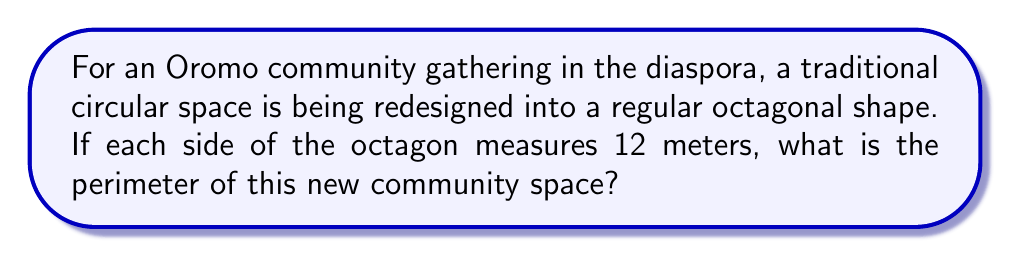Solve this math problem. Let's approach this step-by-step:

1) First, recall that a regular octagon has 8 equal sides.

2) We are given that each side measures 12 meters.

3) To find the perimeter, we need to sum up the lengths of all sides.

4) In mathematical terms, this can be expressed as:

   $$\text{Perimeter} = 8 \times \text{side length}$$

5) Substituting the given side length:

   $$\text{Perimeter} = 8 \times 12\text{ m}$$

6) Performing the multiplication:

   $$\text{Perimeter} = 96\text{ m}$$

Therefore, the perimeter of the octagonal community gathering space is 96 meters.
Answer: 96 m 